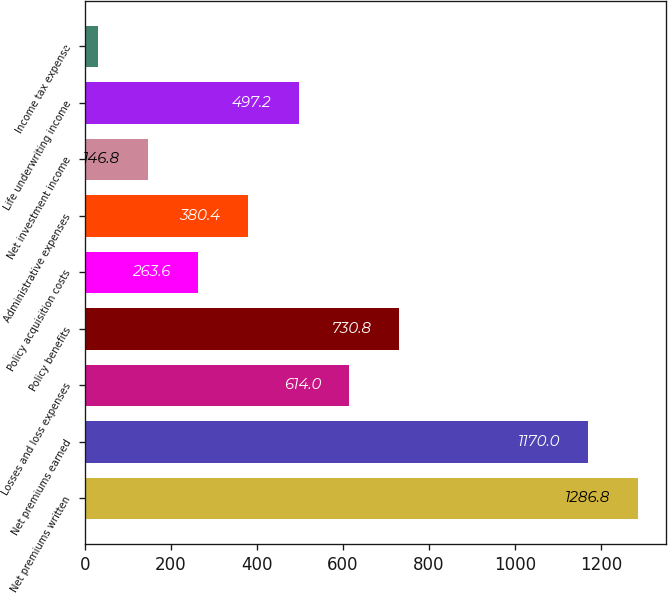Convert chart. <chart><loc_0><loc_0><loc_500><loc_500><bar_chart><fcel>Net premiums written<fcel>Net premiums earned<fcel>Losses and loss expenses<fcel>Policy benefits<fcel>Policy acquisition costs<fcel>Administrative expenses<fcel>Net investment income<fcel>Life underwriting income<fcel>Income tax expense<nl><fcel>1286.8<fcel>1170<fcel>614<fcel>730.8<fcel>263.6<fcel>380.4<fcel>146.8<fcel>497.2<fcel>30<nl></chart> 